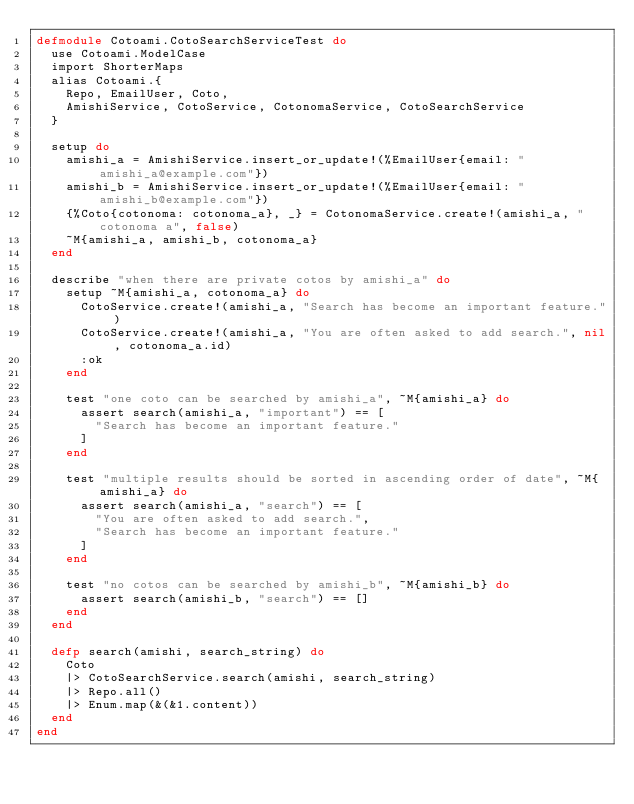Convert code to text. <code><loc_0><loc_0><loc_500><loc_500><_Elixir_>defmodule Cotoami.CotoSearchServiceTest do
  use Cotoami.ModelCase
  import ShorterMaps
  alias Cotoami.{
    Repo, EmailUser, Coto,
    AmishiService, CotoService, CotonomaService, CotoSearchService
  }

  setup do
    amishi_a = AmishiService.insert_or_update!(%EmailUser{email: "amishi_a@example.com"})
    amishi_b = AmishiService.insert_or_update!(%EmailUser{email: "amishi_b@example.com"})
    {%Coto{cotonoma: cotonoma_a}, _} = CotonomaService.create!(amishi_a, "cotonoma a", false)
    ~M{amishi_a, amishi_b, cotonoma_a}
  end

  describe "when there are private cotos by amishi_a" do
    setup ~M{amishi_a, cotonoma_a} do
      CotoService.create!(amishi_a, "Search has become an important feature.")
      CotoService.create!(amishi_a, "You are often asked to add search.", nil, cotonoma_a.id)
      :ok
    end

    test "one coto can be searched by amishi_a", ~M{amishi_a} do
      assert search(amishi_a, "important") == [
        "Search has become an important feature."
      ]
    end

    test "multiple results should be sorted in ascending order of date", ~M{amishi_a} do
      assert search(amishi_a, "search") == [
        "You are often asked to add search.",
        "Search has become an important feature."
      ]
    end

    test "no cotos can be searched by amishi_b", ~M{amishi_b} do
      assert search(amishi_b, "search") == []
    end
  end

  defp search(amishi, search_string) do
    Coto
    |> CotoSearchService.search(amishi, search_string)
    |> Repo.all()
    |> Enum.map(&(&1.content))
  end
end

</code> 